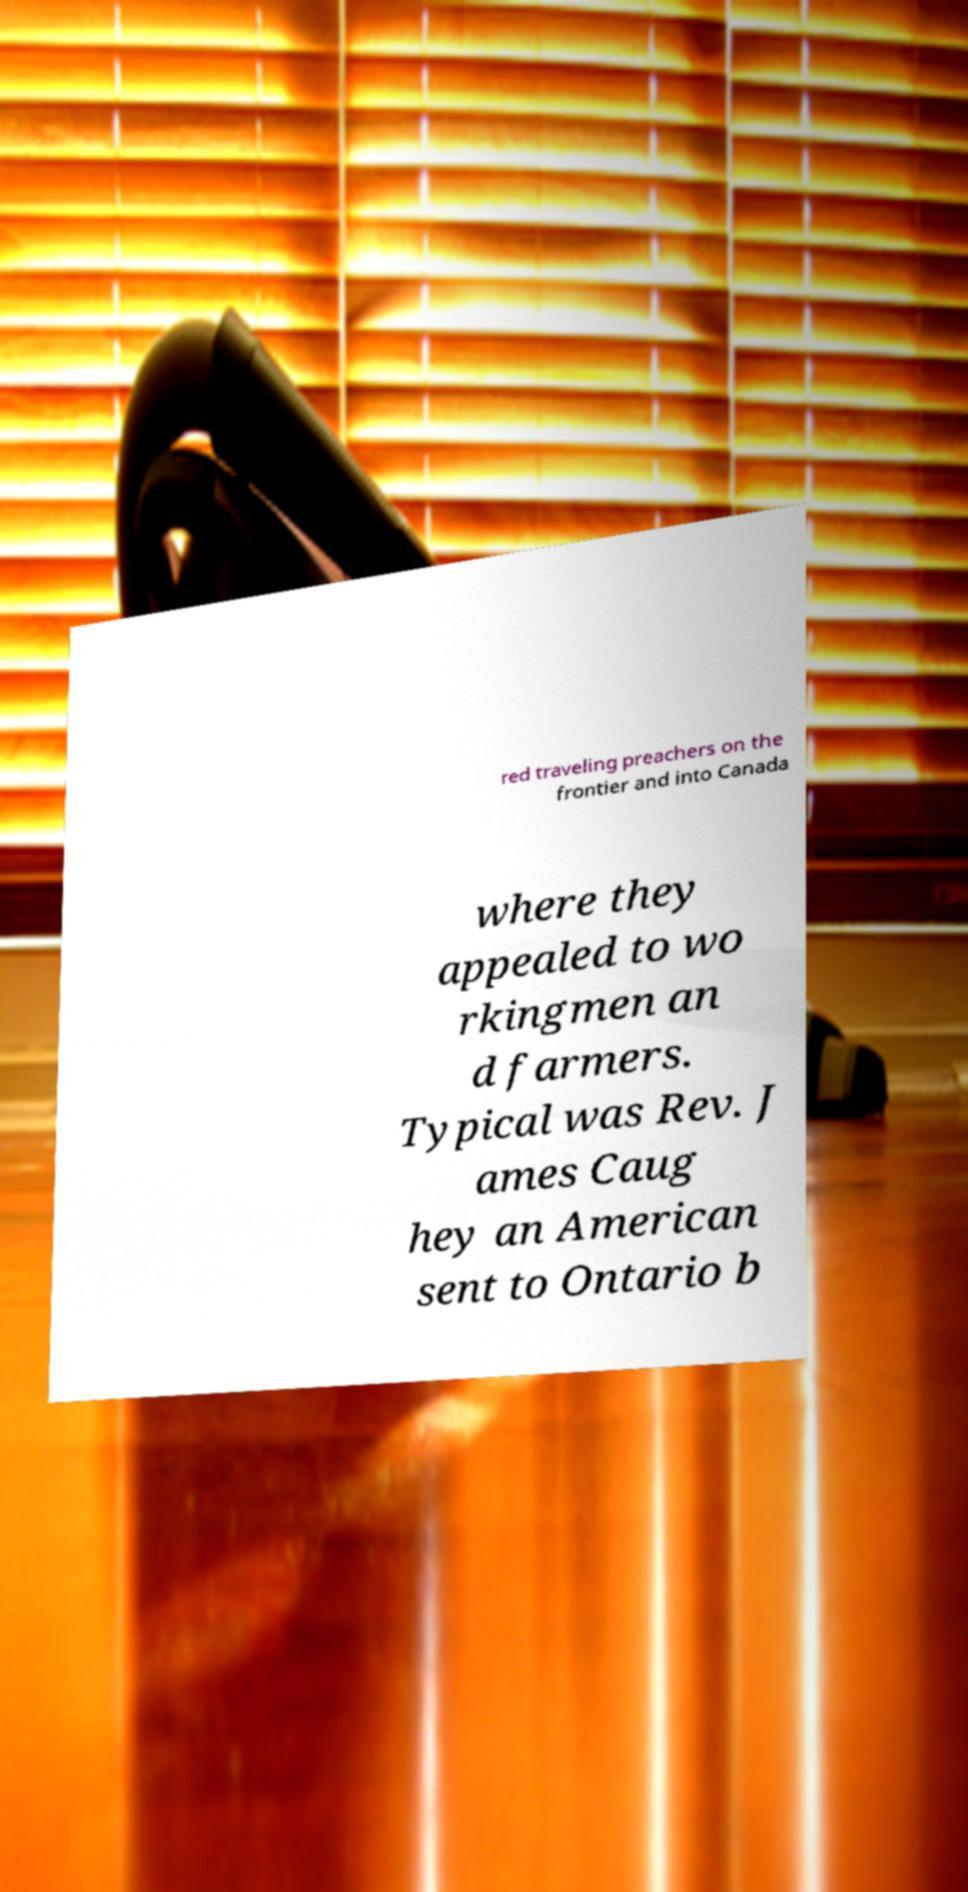I need the written content from this picture converted into text. Can you do that? red traveling preachers on the frontier and into Canada where they appealed to wo rkingmen an d farmers. Typical was Rev. J ames Caug hey an American sent to Ontario b 